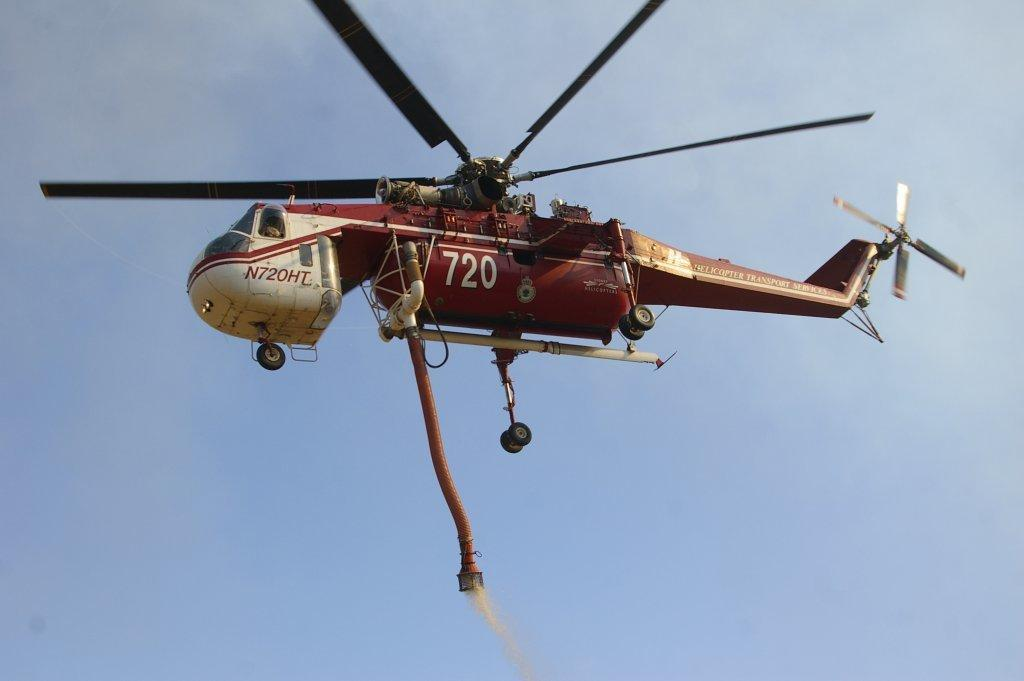What is the main subject in the center of the image? There is a copter in the center of the image. What can be seen in the background of the image? The sky is visible in the background of the image. What type of bun is being used to lead the copter in the image? There is no bun or any indication of leading in the image; it simply features a copter in the center and the sky in the background. 